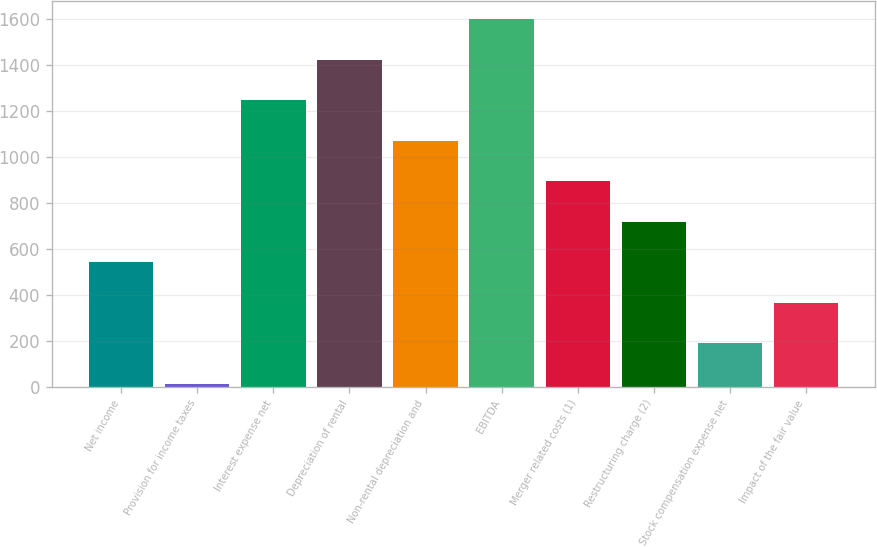Convert chart to OTSL. <chart><loc_0><loc_0><loc_500><loc_500><bar_chart><fcel>Net income<fcel>Provision for income taxes<fcel>Interest expense net<fcel>Depreciation of rental<fcel>Non-rental depreciation and<fcel>EBITDA<fcel>Merger related costs (1)<fcel>Restructuring charge (2)<fcel>Stock compensation expense net<fcel>Impact of the fair value<nl><fcel>540.7<fcel>13<fcel>1244.3<fcel>1420.2<fcel>1068.4<fcel>1596.1<fcel>892.5<fcel>716.6<fcel>188.9<fcel>364.8<nl></chart> 